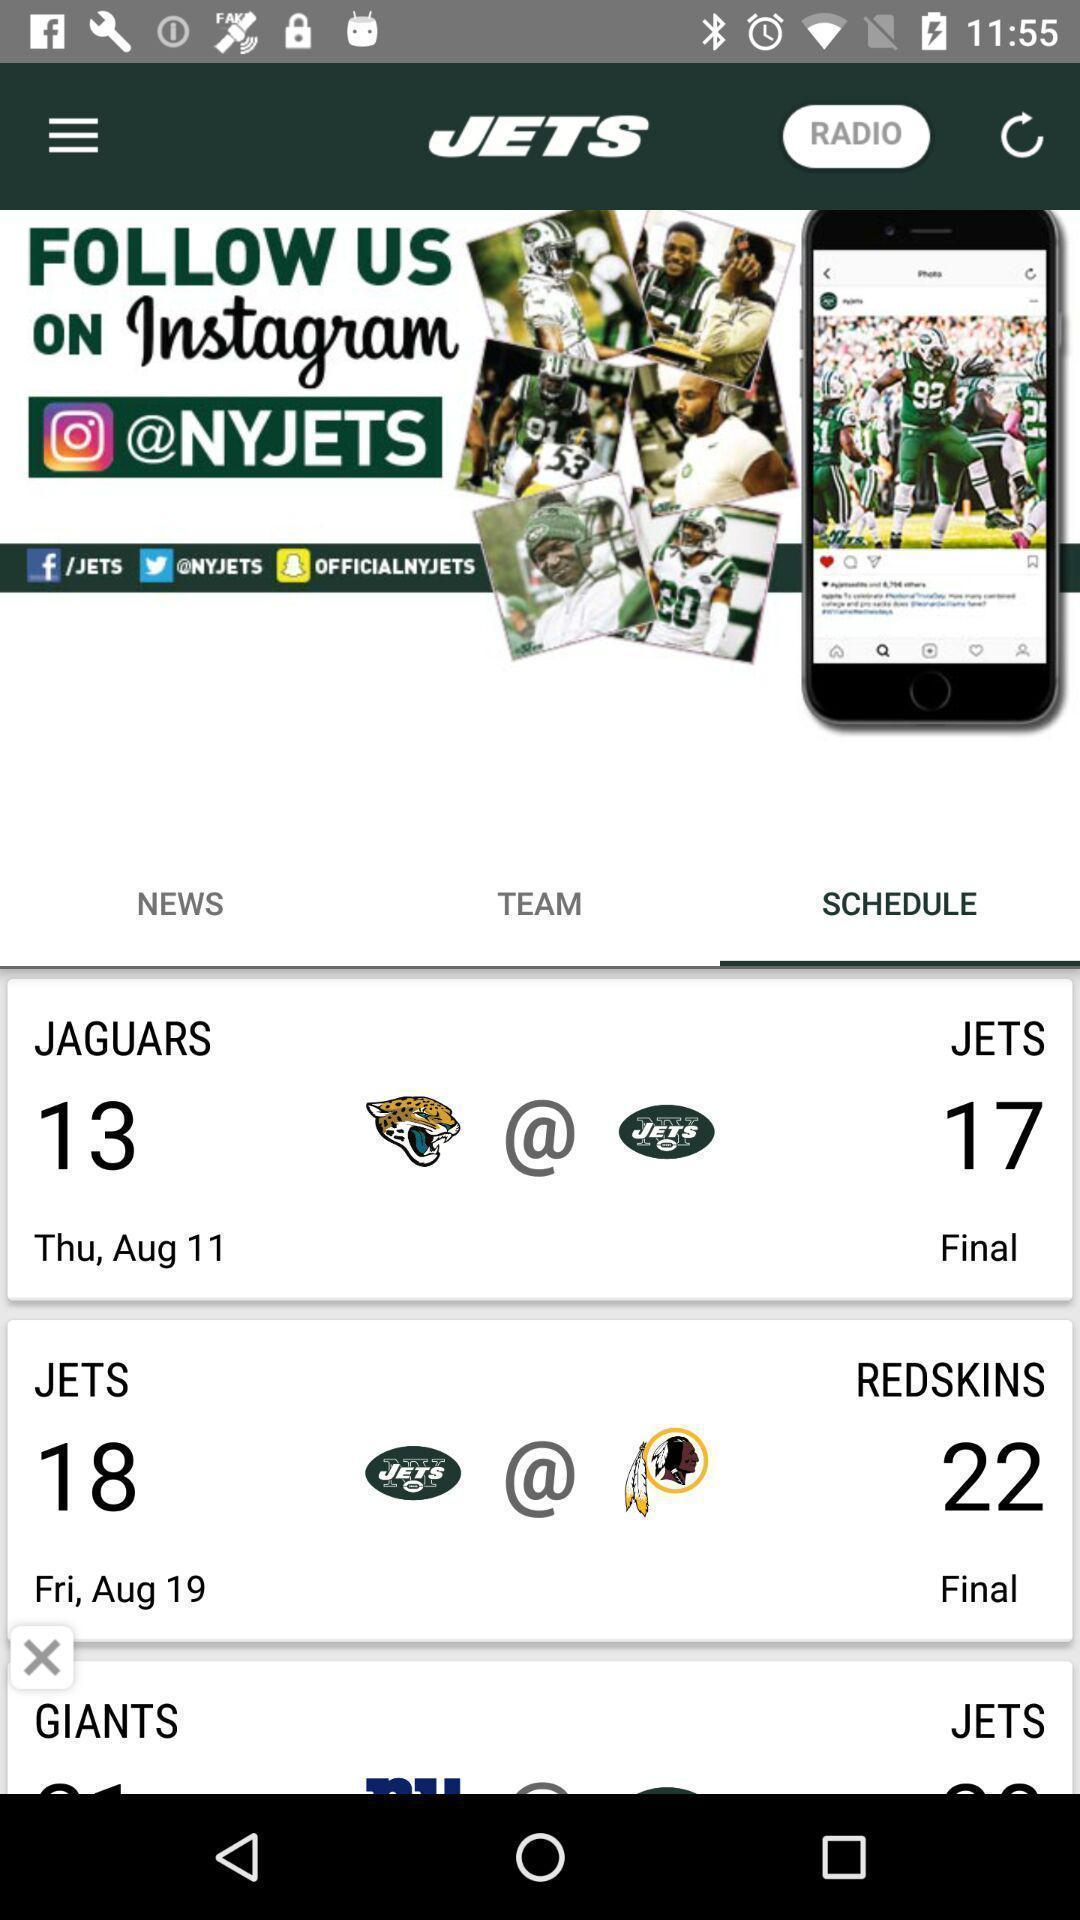Summarize the main components in this picture. Screen shows schedule details in a news app. 